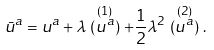<formula> <loc_0><loc_0><loc_500><loc_500>\bar { u } ^ { a } = u ^ { a } + \lambda \stackrel { ( 1 ) } { ( u ^ { a } ) } + \frac { 1 } { 2 } \lambda ^ { 2 } \stackrel { ( 2 ) } { ( u ^ { a } ) } .</formula> 